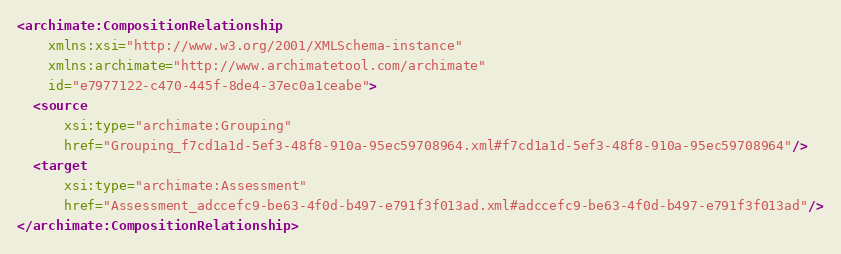Convert code to text. <code><loc_0><loc_0><loc_500><loc_500><_XML_><archimate:CompositionRelationship
    xmlns:xsi="http://www.w3.org/2001/XMLSchema-instance"
    xmlns:archimate="http://www.archimatetool.com/archimate"
    id="e7977122-c470-445f-8de4-37ec0a1ceabe">
  <source
      xsi:type="archimate:Grouping"
      href="Grouping_f7cd1a1d-5ef3-48f8-910a-95ec59708964.xml#f7cd1a1d-5ef3-48f8-910a-95ec59708964"/>
  <target
      xsi:type="archimate:Assessment"
      href="Assessment_adccefc9-be63-4f0d-b497-e791f3f013ad.xml#adccefc9-be63-4f0d-b497-e791f3f013ad"/>
</archimate:CompositionRelationship>
</code> 